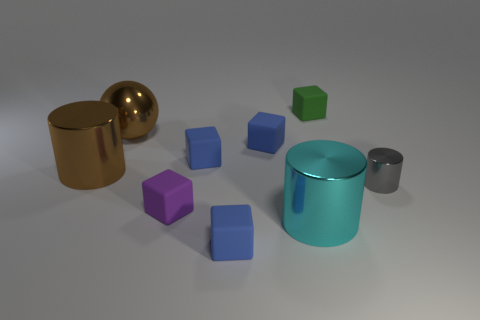There is a large cylinder behind the gray metallic cylinder; is its color the same as the big object right of the tiny purple rubber object?
Ensure brevity in your answer.  No. Are there any other things of the same color as the large sphere?
Keep it short and to the point. Yes. There is a big cylinder that is behind the cylinder that is right of the green thing; what color is it?
Keep it short and to the point. Brown. Is there a rubber object?
Provide a short and direct response. Yes. What color is the large object that is on the right side of the big brown cylinder and left of the cyan metallic cylinder?
Give a very brief answer. Brown. Do the blue rubber object that is in front of the purple block and the object that is on the right side of the tiny green rubber block have the same size?
Make the answer very short. Yes. What number of other things are there of the same size as the gray thing?
Your response must be concise. 5. There is a purple matte thing in front of the tiny gray shiny object; how many cylinders are behind it?
Give a very brief answer. 2. Are there fewer small cubes left of the cyan metal object than cyan matte things?
Keep it short and to the point. No. What shape is the matte object that is behind the brown metallic thing behind the brown object that is left of the brown metallic sphere?
Your response must be concise. Cube. 